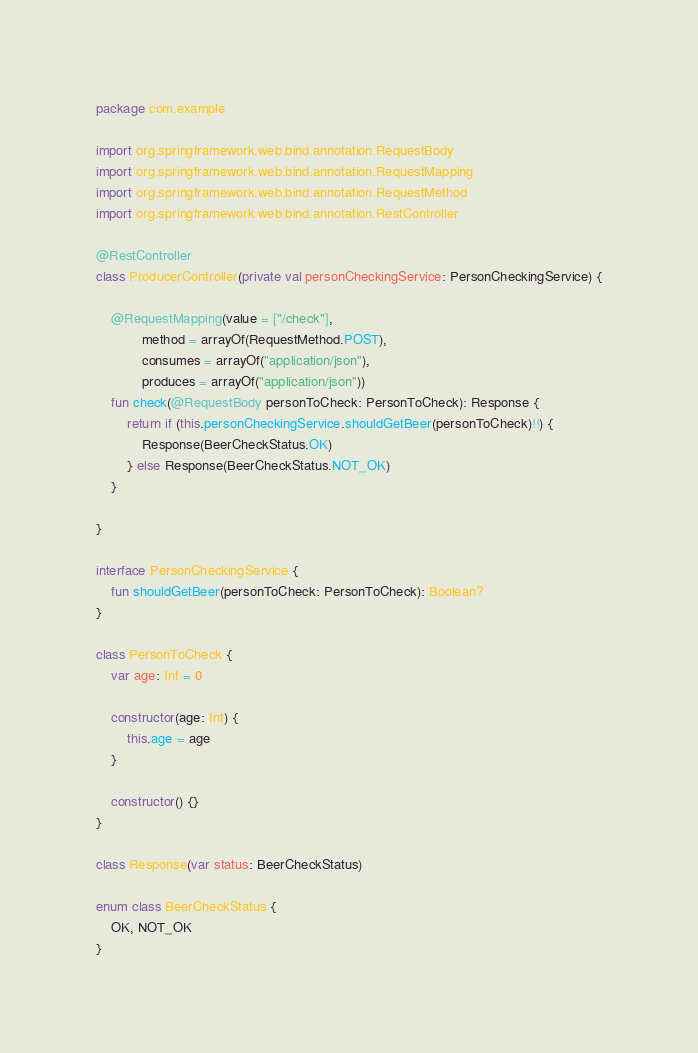<code> <loc_0><loc_0><loc_500><loc_500><_Kotlin_>package com.example

import org.springframework.web.bind.annotation.RequestBody
import org.springframework.web.bind.annotation.RequestMapping
import org.springframework.web.bind.annotation.RequestMethod
import org.springframework.web.bind.annotation.RestController

@RestController
class ProducerController(private val personCheckingService: PersonCheckingService) {

    @RequestMapping(value = ["/check"],
            method = arrayOf(RequestMethod.POST),
            consumes = arrayOf("application/json"),
            produces = arrayOf("application/json"))
    fun check(@RequestBody personToCheck: PersonToCheck): Response {
        return if (this.personCheckingService.shouldGetBeer(personToCheck)!!) {
            Response(BeerCheckStatus.OK)
        } else Response(BeerCheckStatus.NOT_OK)
    }

}

interface PersonCheckingService {
    fun shouldGetBeer(personToCheck: PersonToCheck): Boolean?
}

class PersonToCheck {
    var age: Int = 0

    constructor(age: Int) {
        this.age = age
    }

    constructor() {}
}

class Response(var status: BeerCheckStatus)

enum class BeerCheckStatus {
    OK, NOT_OK
}</code> 